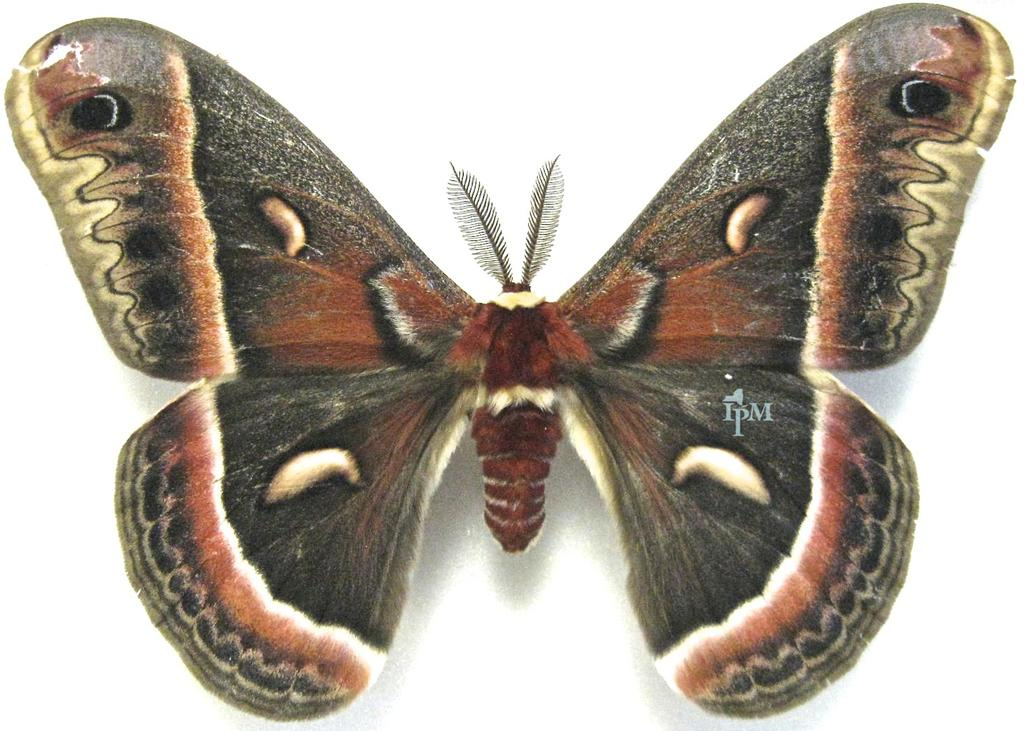What type of animal can be seen in the image? There is a butterfly in the image. Can you describe any additional features of the image? Yes, there is a watermark in the image. What color is the background of the image? The background of the image is white. What type of war is depicted in the image? There is no war depicted in the image; it features a butterfly and a watermark on a white background. Can you describe the tiger's behavior in the image? There is no tiger present in the image. 